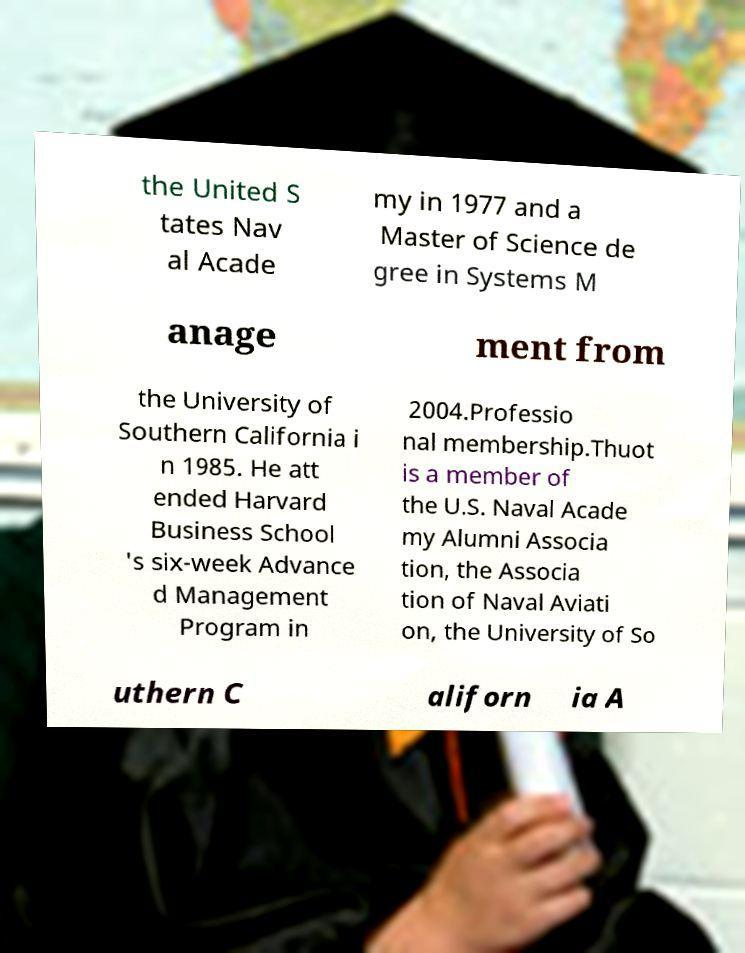For documentation purposes, I need the text within this image transcribed. Could you provide that? the United S tates Nav al Acade my in 1977 and a Master of Science de gree in Systems M anage ment from the University of Southern California i n 1985. He att ended Harvard Business School 's six-week Advance d Management Program in 2004.Professio nal membership.Thuot is a member of the U.S. Naval Acade my Alumni Associa tion, the Associa tion of Naval Aviati on, the University of So uthern C aliforn ia A 